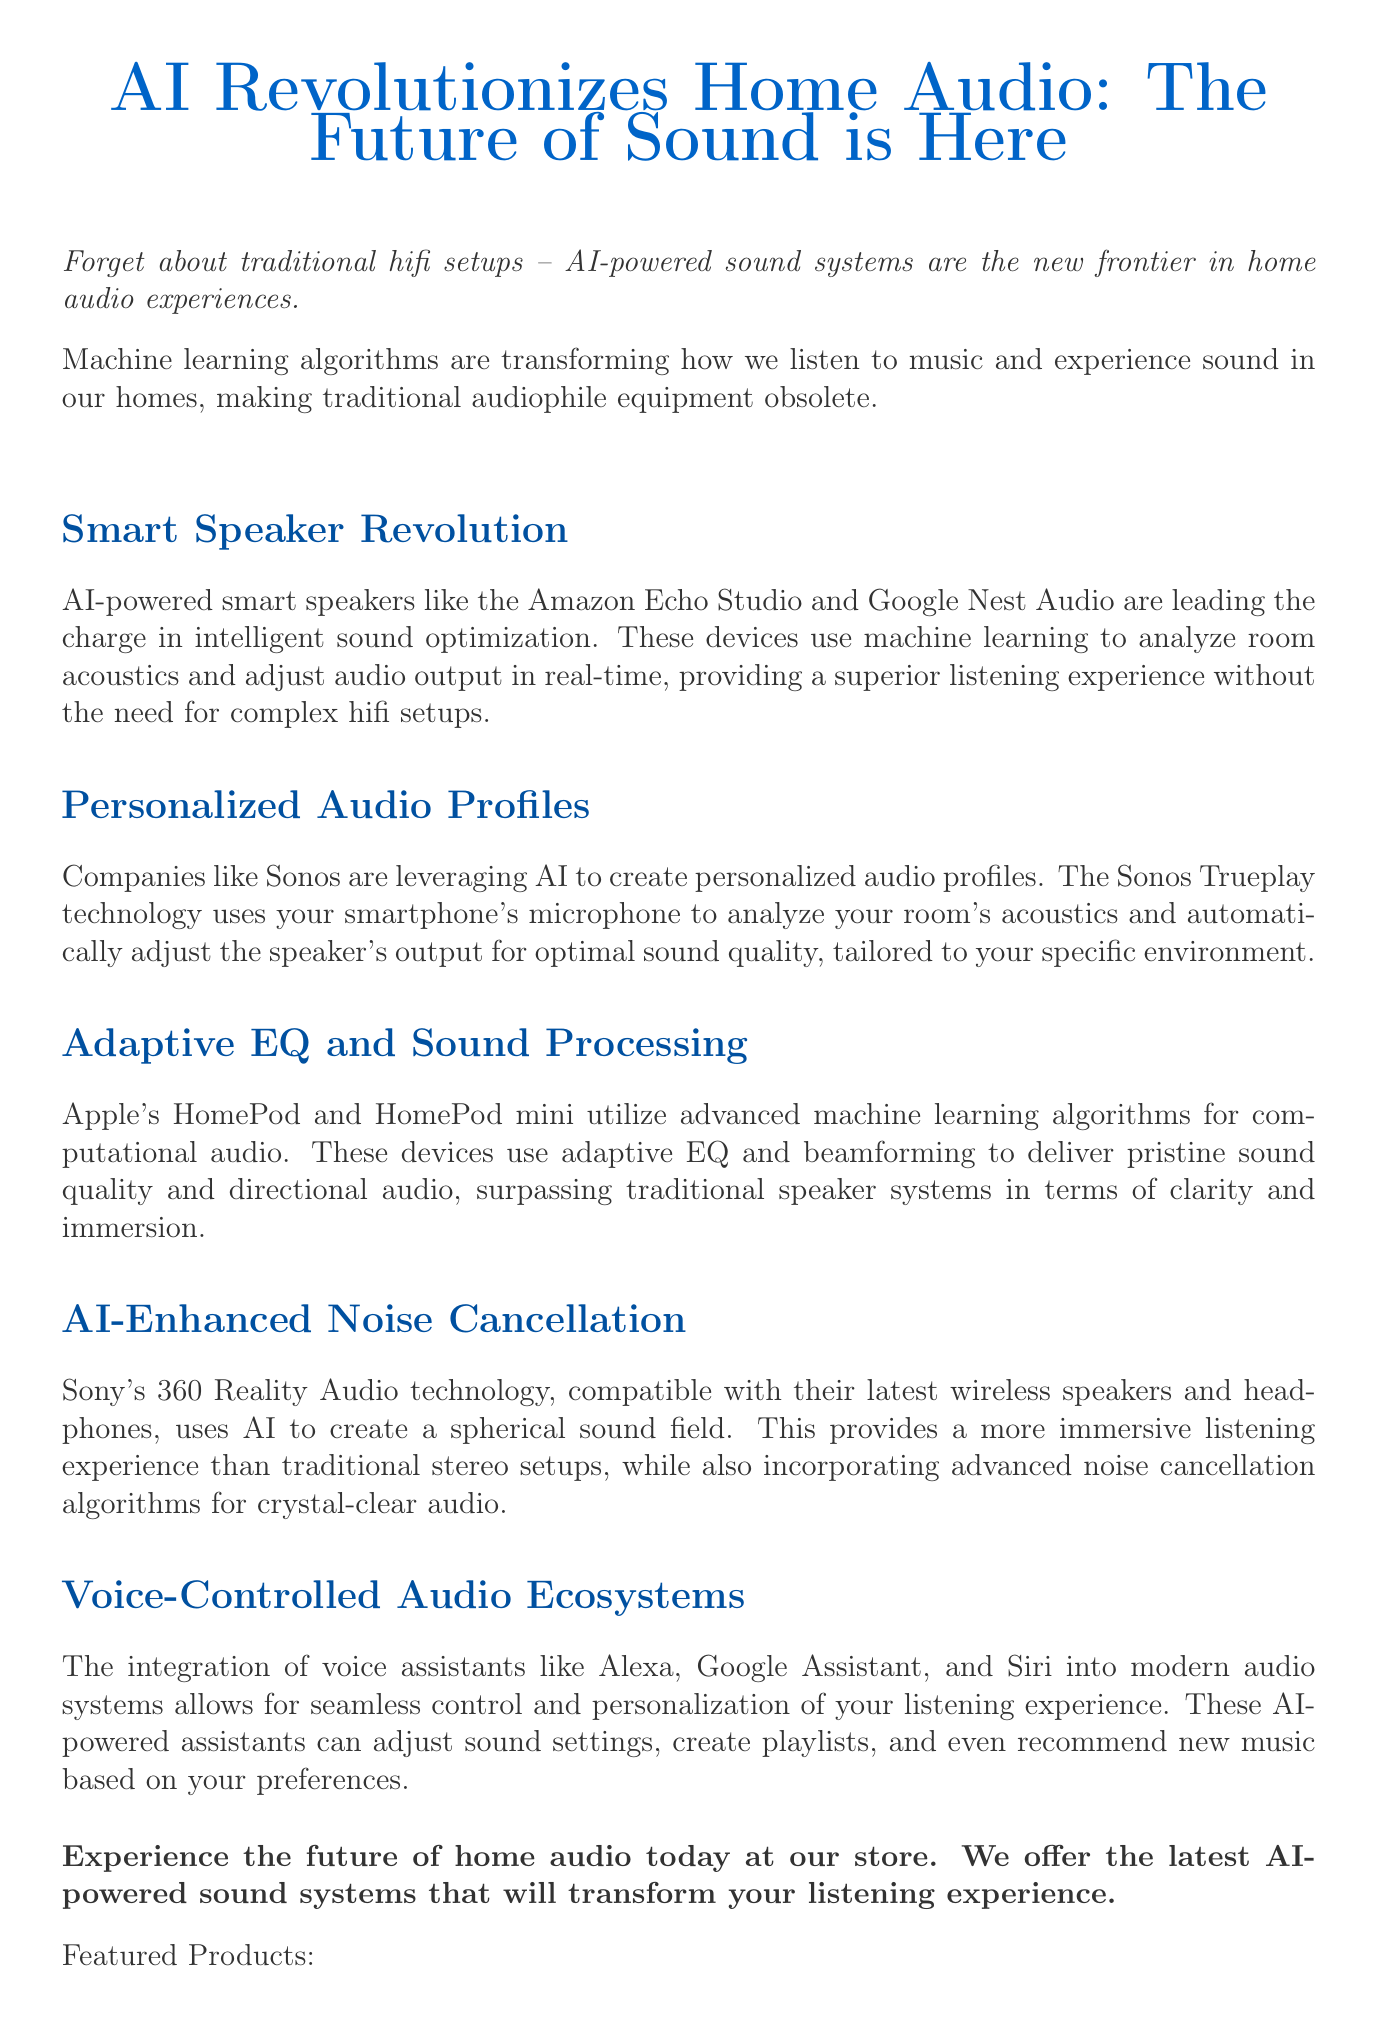What is the title of the newsletter? The title is explicitly stated at the beginning of the document.
Answer: AI Revolutionizes Home Audio: The Future of Sound is Here Which AI-powered smart speakers are mentioned? The document lists specific smart speakers in the section discussing smart speakers.
Answer: Amazon Echo Studio and Google Nest Audio What technology does Sonos use for personalized audio profiles? The document specifically mentions the technology employed by Sonos for creating audio profiles.
Answer: Trueplay What feature do Apple HomePod devices utilize for sound quality? The document notes a specific technology used by Apple devices to improve sound.
Answer: Computational audio Which company offers AI-enhanced noise cancellation technology? The document indicates which company's technology focuses on this feature.
Answer: Sony What is the primary call to action in the newsletter? The document describes the main action it encourages readers to take.
Answer: Experience the future of home audio today at our store How many featured products are listed? The document contains a list of products, providing the total number mentioned.
Answer: Five What is predicted for the future of AI in home audio? The conclusion section mentions expectations for future developments in the field.
Answer: More advanced sound optimization techniques 